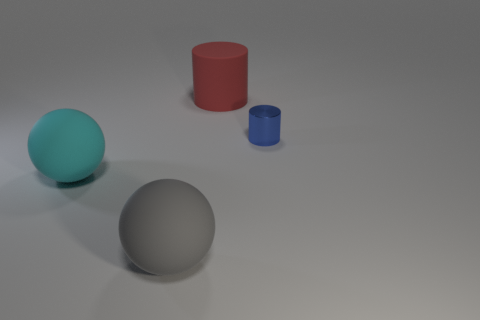Is there any other thing that has the same material as the small thing?
Your answer should be compact. No. The big matte cylinder to the right of the thing that is in front of the cyan rubber object is what color?
Provide a short and direct response. Red. Are there fewer shiny objects that are left of the metal thing than blue things right of the big red cylinder?
Your answer should be compact. Yes. Is the size of the red rubber thing the same as the gray matte thing?
Provide a succinct answer. Yes. There is a thing that is in front of the red matte object and on the right side of the big gray matte thing; what is its shape?
Provide a succinct answer. Cylinder. What number of cyan objects are made of the same material as the big red object?
Provide a short and direct response. 1. There is a object behind the shiny thing; how many large spheres are right of it?
Provide a succinct answer. 0. There is a thing to the right of the big thing on the right side of the large matte ball in front of the cyan matte object; what is its shape?
Make the answer very short. Cylinder. What number of things are either big cylinders or big balls?
Provide a short and direct response. 3. There is another sphere that is the same size as the gray ball; what is its color?
Give a very brief answer. Cyan. 